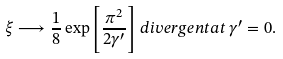Convert formula to latex. <formula><loc_0><loc_0><loc_500><loc_500>\xi \longrightarrow \frac { 1 } { 8 } \exp \left [ \frac { \pi ^ { 2 } } { 2 \gamma ^ { \prime } } \right ] \, d i v e r g e n t a t \, \gamma ^ { \prime } = 0 .</formula> 